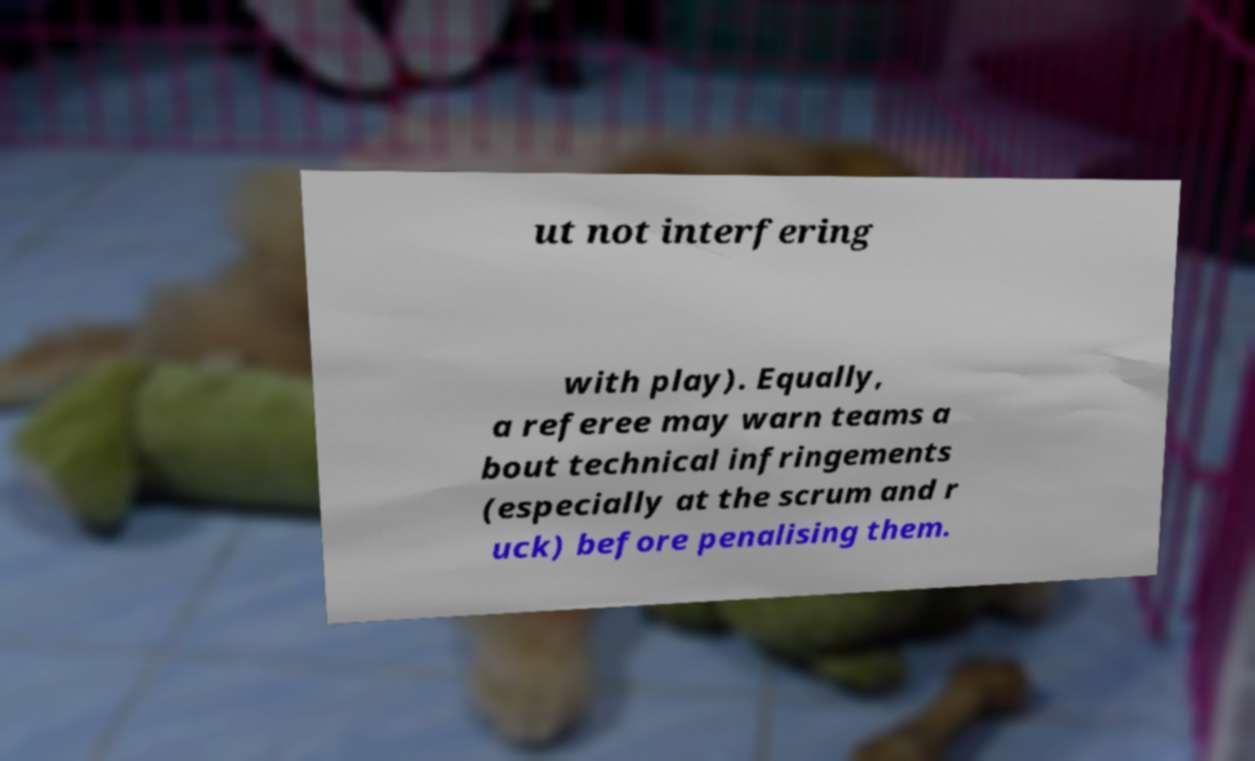What messages or text are displayed in this image? I need them in a readable, typed format. ut not interfering with play). Equally, a referee may warn teams a bout technical infringements (especially at the scrum and r uck) before penalising them. 